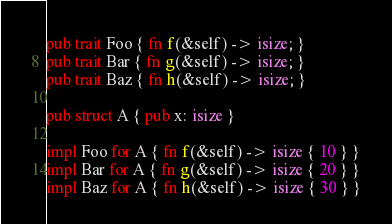<code> <loc_0><loc_0><loc_500><loc_500><_Rust_>pub trait Foo { fn f(&self) -> isize; }
pub trait Bar { fn g(&self) -> isize; }
pub trait Baz { fn h(&self) -> isize; }

pub struct A { pub x: isize }

impl Foo for A { fn f(&self) -> isize { 10 } }
impl Bar for A { fn g(&self) -> isize { 20 } }
impl Baz for A { fn h(&self) -> isize { 30 } }
</code> 